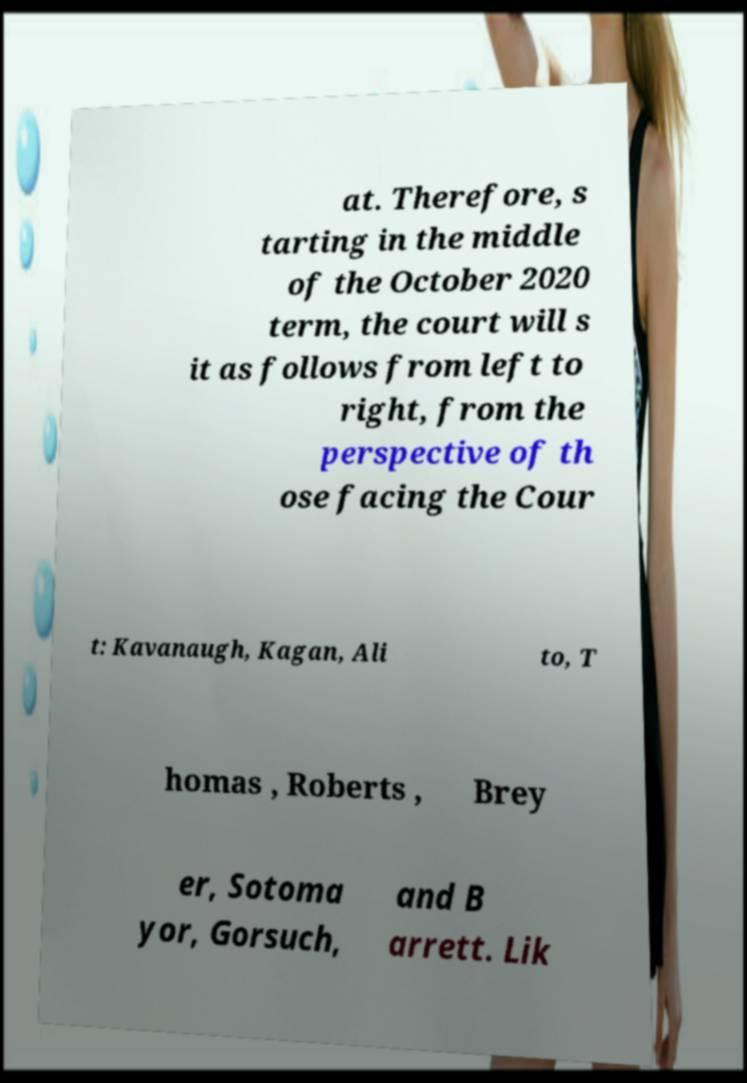Please identify and transcribe the text found in this image. at. Therefore, s tarting in the middle of the October 2020 term, the court will s it as follows from left to right, from the perspective of th ose facing the Cour t: Kavanaugh, Kagan, Ali to, T homas , Roberts , Brey er, Sotoma yor, Gorsuch, and B arrett. Lik 